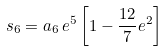Convert formula to latex. <formula><loc_0><loc_0><loc_500><loc_500>s _ { 6 } = a _ { 6 } \, e ^ { 5 } \left [ 1 - \frac { 1 2 } { 7 } e ^ { 2 } \right ]</formula> 